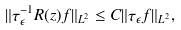Convert formula to latex. <formula><loc_0><loc_0><loc_500><loc_500>\| \tau _ { \epsilon } ^ { - 1 } R ( z ) f \| _ { L ^ { 2 } } \leq C \| \tau _ { \epsilon } f \| _ { L ^ { 2 } } ,</formula> 